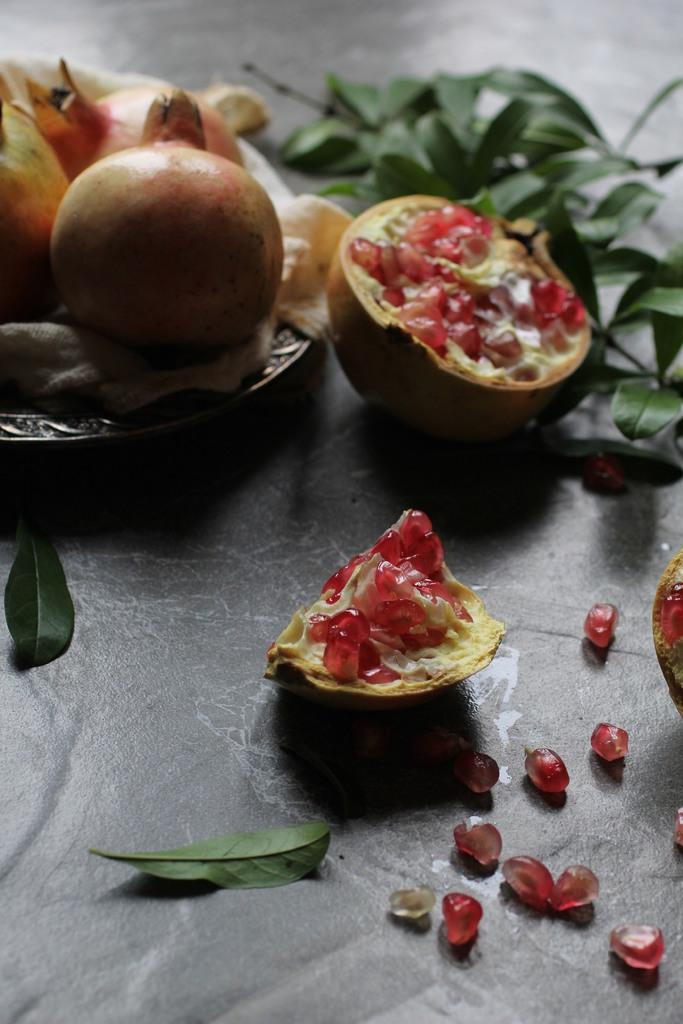What type of food items can be seen in the image? There are fruits in the image. What else is present in the image besides the fruits? There are leaves in the image. What is the color of the surface in the image? The surface in the image is black in color. What type of grass is visible in the image? There is no grass present in the image. Can you tell me what the secretary is doing in the image? There is no secretary present in the image. 